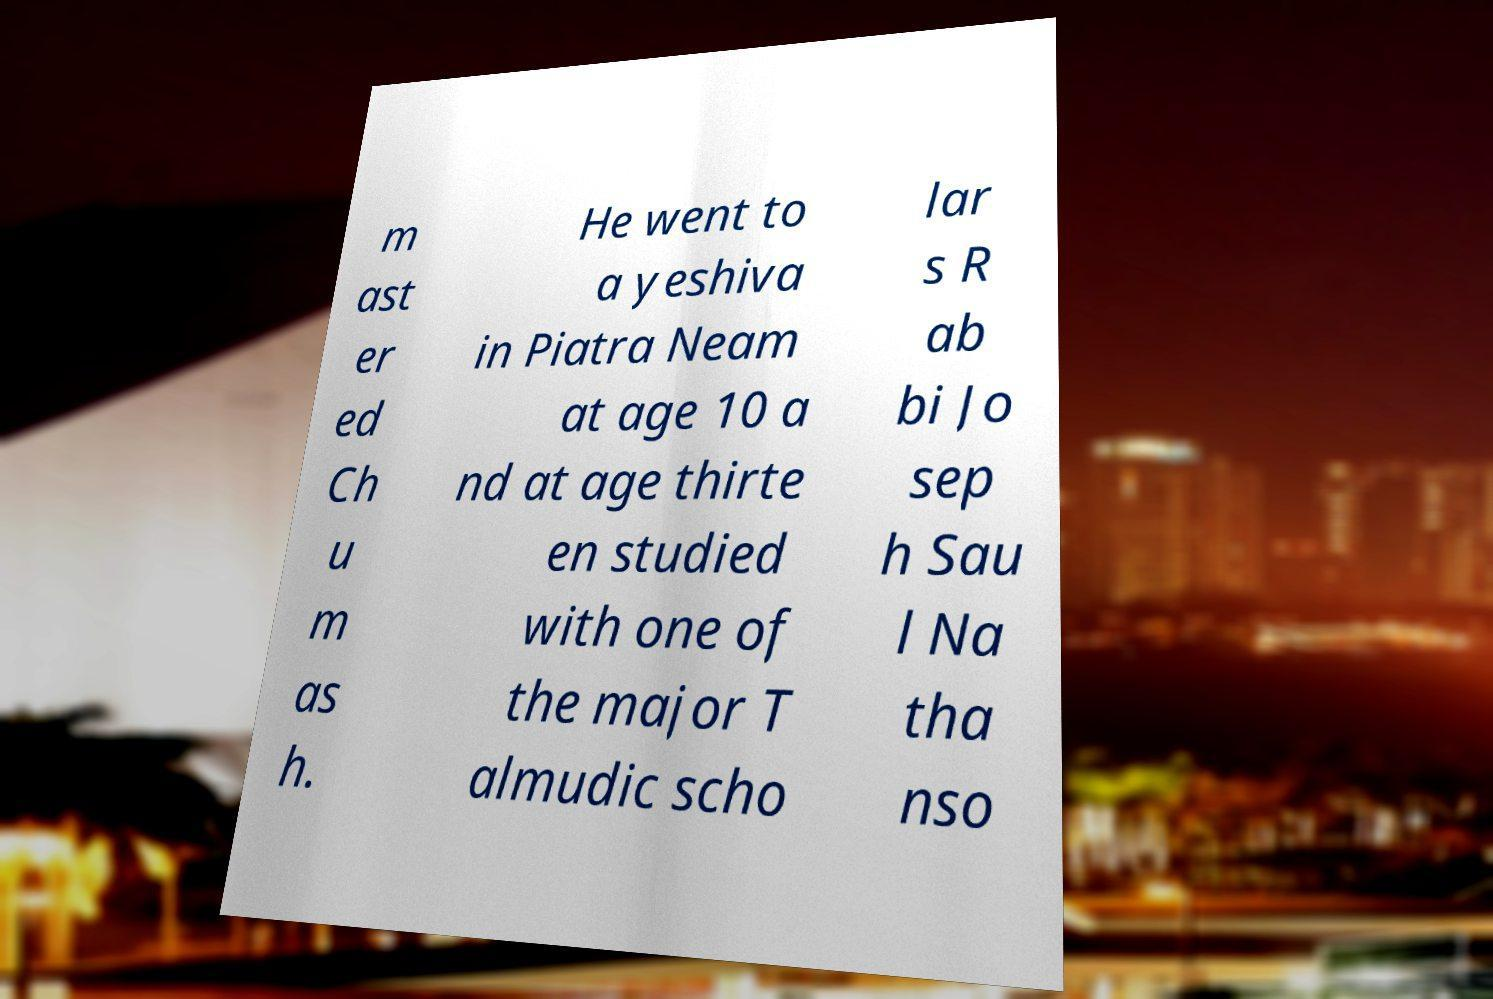I need the written content from this picture converted into text. Can you do that? m ast er ed Ch u m as h. He went to a yeshiva in Piatra Neam at age 10 a nd at age thirte en studied with one of the major T almudic scho lar s R ab bi Jo sep h Sau l Na tha nso 